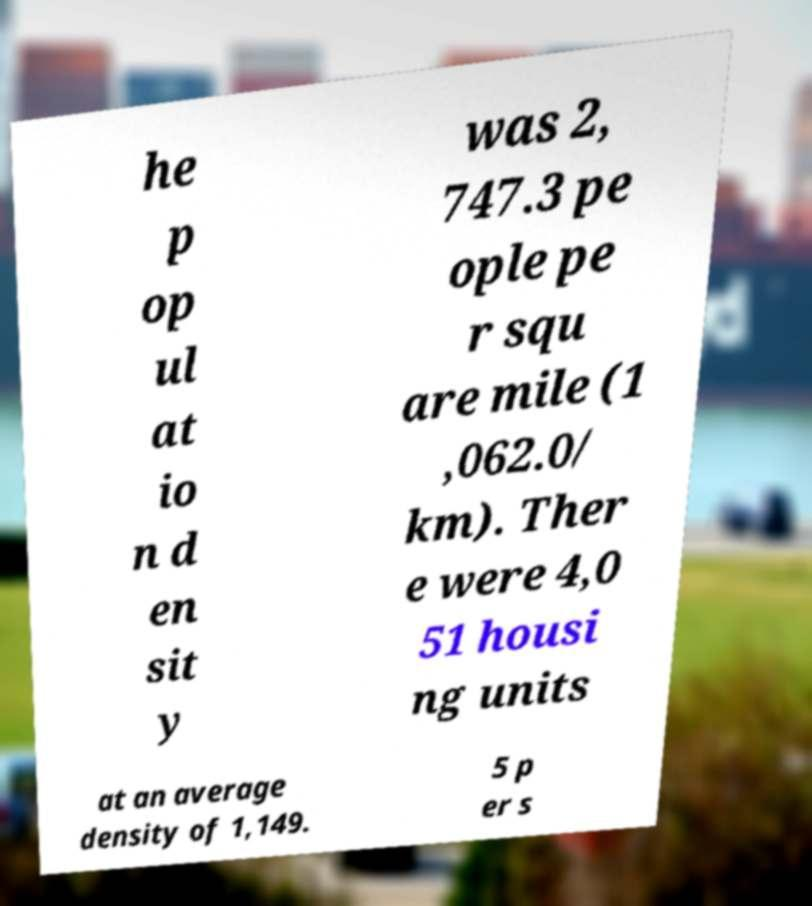Could you extract and type out the text from this image? he p op ul at io n d en sit y was 2, 747.3 pe ople pe r squ are mile (1 ,062.0/ km). Ther e were 4,0 51 housi ng units at an average density of 1,149. 5 p er s 